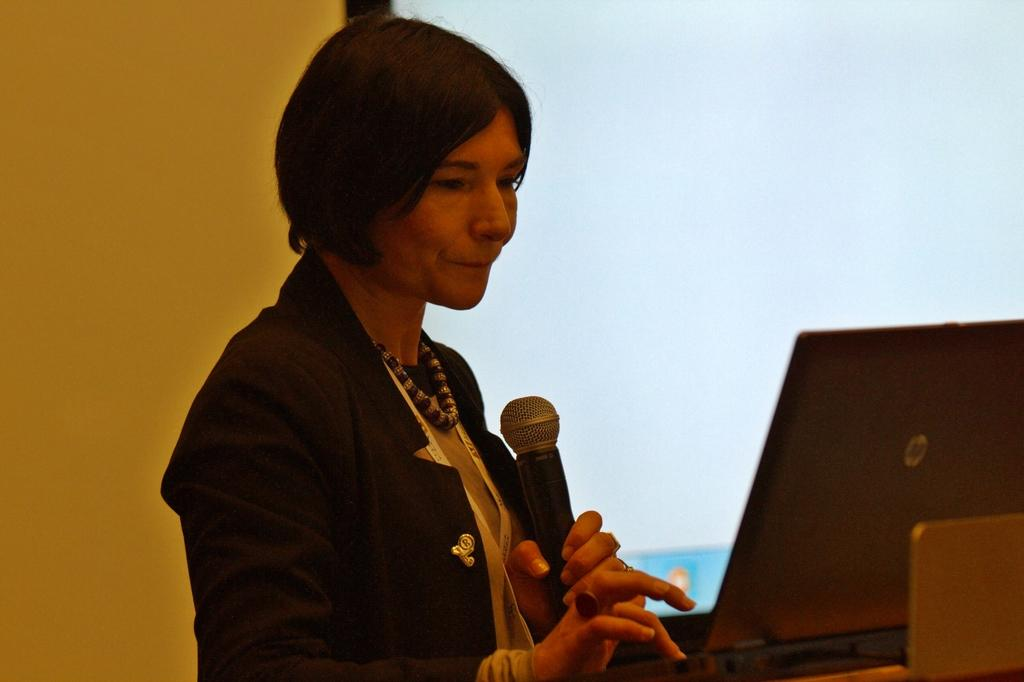Who is the main subject in the image? There is a woman in the image. What is the woman holding in the image? The woman is holding a microphone. What electronic device is visible in front of the woman? There is a laptop visible in front of the woman. What type of fog can be seen in the image? There is no fog present in the image. 